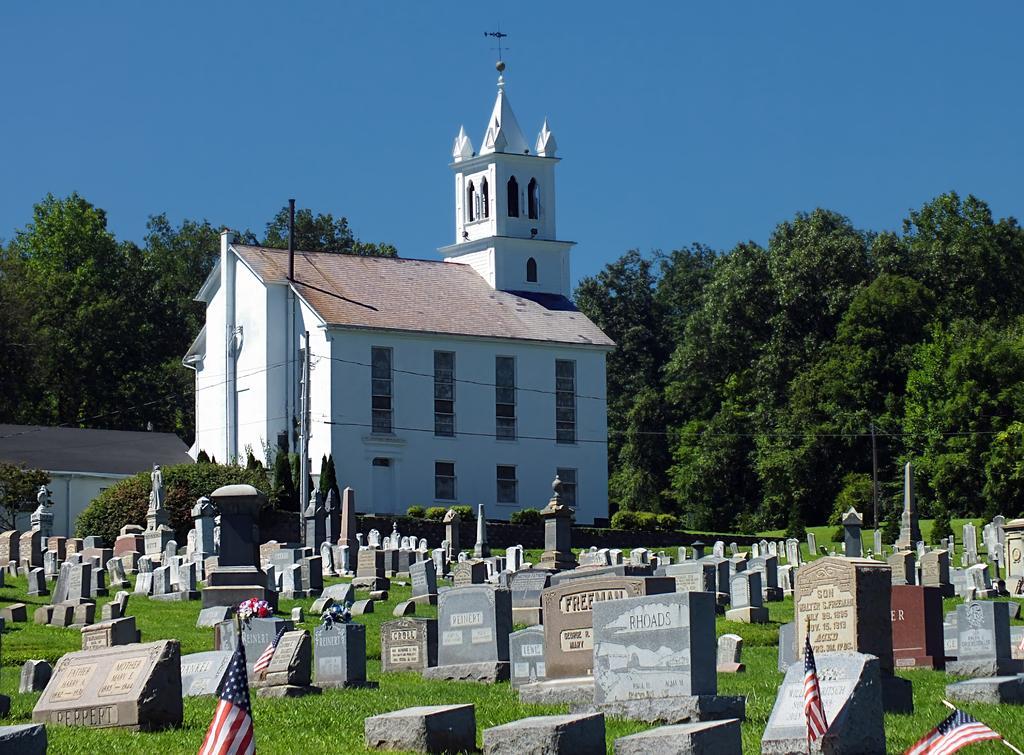How would you summarize this image in a sentence or two? At the bottom of the picture, we see graves in the graveyard. We even see the grass and the flags in white, red and blue color. Behind that, we see buildings in white color. There are trees in the background. At the top of the picture, we see the sky, which is blue in color. 